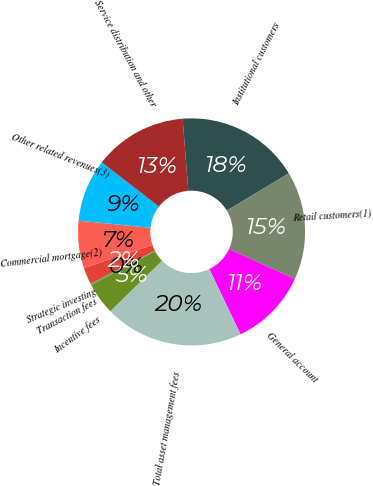Convert chart to OTSL. <chart><loc_0><loc_0><loc_500><loc_500><pie_chart><fcel>Institutional customers<fcel>Retail customers(1)<fcel>General account<fcel>Total asset management fees<fcel>Incentive fees<fcel>Transaction fees<fcel>Strategic investing<fcel>Commercial mortgage(2)<fcel>Other related revenues(3)<fcel>Service distribution and other<nl><fcel>17.62%<fcel>15.44%<fcel>11.09%<fcel>19.79%<fcel>4.56%<fcel>0.21%<fcel>2.38%<fcel>6.74%<fcel>8.91%<fcel>13.26%<nl></chart> 